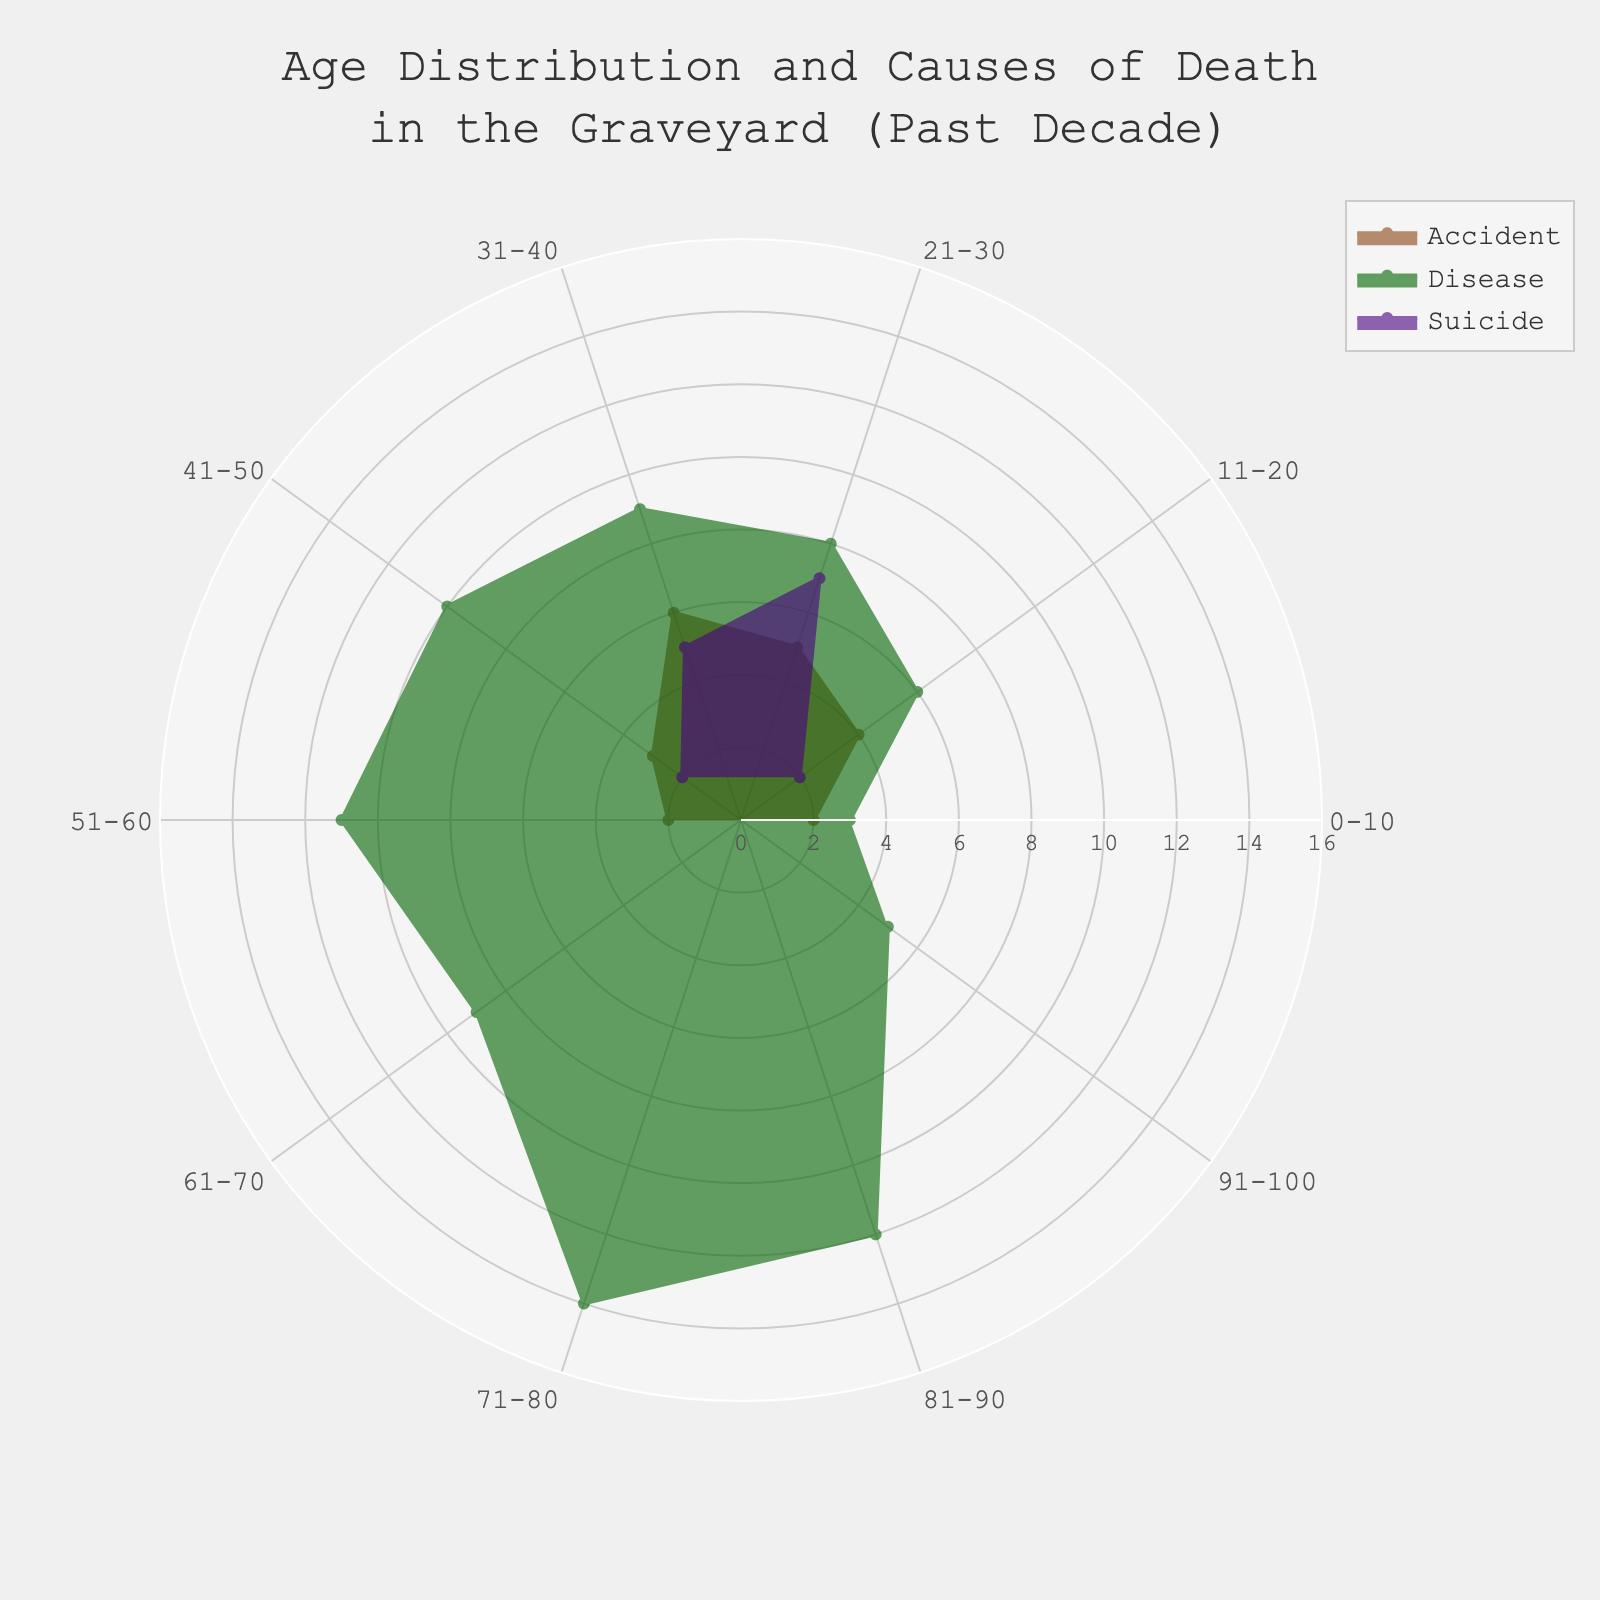What are the age groups shown in the plot? The age groups are listed along the angular axis of the polar chart. By inspecting the plot, we can identify all the age groups presented.
Answer: 0-10, 11-20, 21-30, 31-40, 41-50, 51-60, 61-70, 71-80, 81-90, 91-100 Which cause of death has the highest count among people aged 21-30? Look at the wedges in the polar plot corresponding to the age group 21-30. The cause with the largest radial extent (distance from the center) in that age group has the highest count.
Answer: Disease What is the overall highest count for any cause of death in the chart? Check all the radial values in the chart and find the maximum radial extent. The highest count in the chart will be the largest value observed radially from the center to the edge.
Answer: 14 In the age group 31-40, how does the count for accidents compare to suicides? In the age group 31-40, look at the radial lengths of the wedges corresponding to accidents and suicides. Compare the lengths to determine which is greater.
Answer: Accidents are higher How many types of causes of death are represented in the polar chart? Check the legend and count the different categories listed, as each type of cause of death is represented as a separate category in the legend.
Answer: 3 Which age group has the highest count of people who died from disease? Identify the maximum radial value for the cause of death labeled “Disease” and check the corresponding age group related to that point on the angular axis.
Answer: 71-80 How does the count of suicide cases in the 21-30 age group compare to the 31-40 age group? Find the radial extents of suicide cases in the 21-30 and 31-40 age groups, then compare the values to determine which is higher.
Answer: 21-30 is higher What is the total count of deaths from accidents across all age groups? Sum up the counts of deaths from accidents for every age group by locating and adding all the relevant radial extents associated with accidents.
Answer: 22 In the age group 51-60, what is the difference in count between deaths due to accidents and deaths due to disease? Identify the radial length for accidents and diseases within the 51-60 age group and calculate the difference between them.
Answer: 9 What is the cause of death with the least number of cases in the age group 41-50? Within the 41-50 age group, look at the wedges corresponding to each cause of death and determine which has the shortest radial length.
Answer: Suicide 